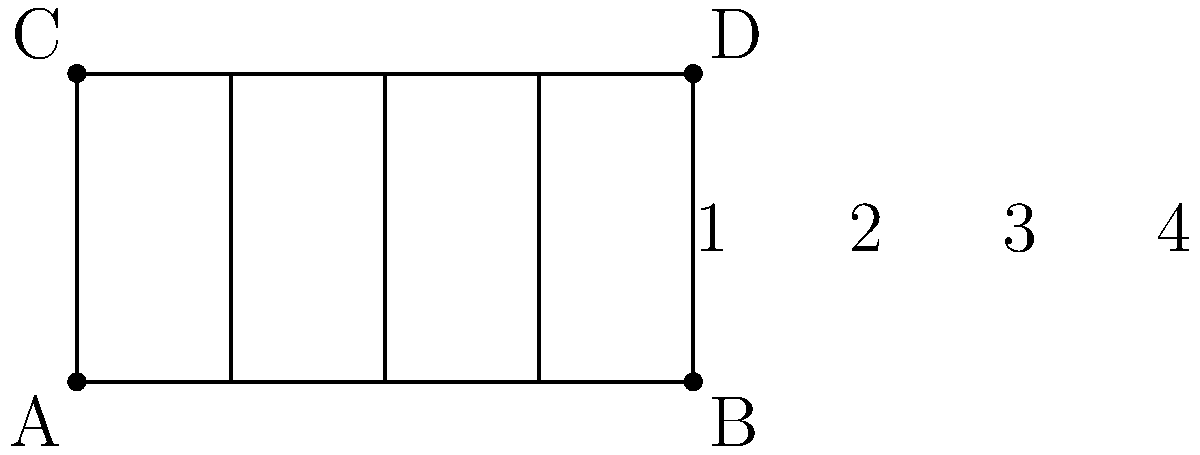In the diagram representing a simplified guitar fretboard, lines AB and CD are parallel. If angle 1 measures 65°, what is the measure of angle 4? To solve this problem, we'll use the properties of angles formed by parallel lines cut by a transversal:

1) In the diagram, AB and CD are parallel lines, and the vertical lines (frets) are transversals.

2) When parallel lines are cut by a transversal, corresponding angles are congruent.

3) Angles 1 and 4 are corresponding angles because they are in the same position relative to the parallel lines and the transversal.

4) Since corresponding angles are congruent, angle 1 and angle 4 must have the same measure.

5) We are given that angle 1 measures 65°.

6) Therefore, angle 4 must also measure 65°.

This concept of corresponding angles being congruent is fundamental in geometry and has applications in various fields, including the design of musical instruments like guitars.
Answer: 65° 